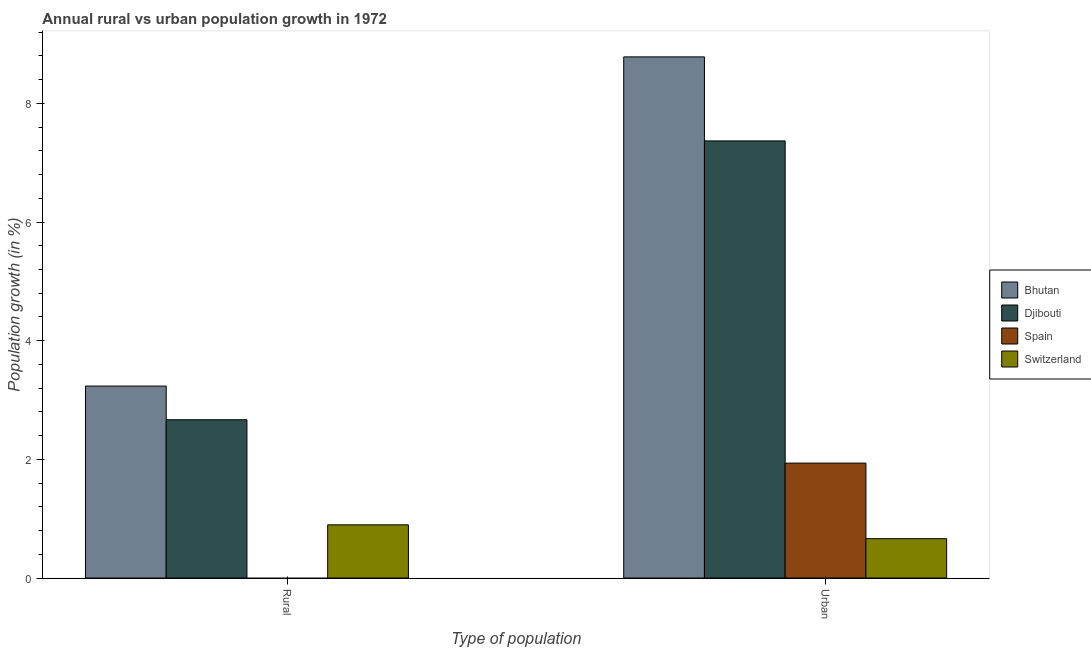Are the number of bars per tick equal to the number of legend labels?
Make the answer very short. No. How many bars are there on the 1st tick from the left?
Your answer should be very brief. 3. How many bars are there on the 1st tick from the right?
Give a very brief answer. 4. What is the label of the 1st group of bars from the left?
Offer a very short reply. Rural. What is the rural population growth in Bhutan?
Keep it short and to the point. 3.24. Across all countries, what is the maximum urban population growth?
Make the answer very short. 8.78. Across all countries, what is the minimum rural population growth?
Provide a short and direct response. 0. In which country was the rural population growth maximum?
Your answer should be very brief. Bhutan. What is the total rural population growth in the graph?
Offer a very short reply. 6.8. What is the difference between the urban population growth in Djibouti and that in Switzerland?
Provide a succinct answer. 6.7. What is the difference between the rural population growth in Spain and the urban population growth in Djibouti?
Keep it short and to the point. -7.37. What is the average rural population growth per country?
Provide a succinct answer. 1.7. What is the difference between the rural population growth and urban population growth in Switzerland?
Offer a terse response. 0.23. What is the ratio of the urban population growth in Spain to that in Bhutan?
Offer a very short reply. 0.22. In how many countries, is the urban population growth greater than the average urban population growth taken over all countries?
Offer a terse response. 2. How many bars are there?
Provide a succinct answer. 7. Are all the bars in the graph horizontal?
Offer a very short reply. No. How many countries are there in the graph?
Provide a short and direct response. 4. Are the values on the major ticks of Y-axis written in scientific E-notation?
Offer a terse response. No. Does the graph contain grids?
Your answer should be compact. No. Where does the legend appear in the graph?
Your answer should be compact. Center right. How many legend labels are there?
Make the answer very short. 4. What is the title of the graph?
Your response must be concise. Annual rural vs urban population growth in 1972. Does "Aruba" appear as one of the legend labels in the graph?
Ensure brevity in your answer.  No. What is the label or title of the X-axis?
Your response must be concise. Type of population. What is the label or title of the Y-axis?
Make the answer very short. Population growth (in %). What is the Population growth (in %) in Bhutan in Rural?
Offer a very short reply. 3.24. What is the Population growth (in %) in Djibouti in Rural?
Keep it short and to the point. 2.67. What is the Population growth (in %) in Spain in Rural?
Your answer should be compact. 0. What is the Population growth (in %) in Switzerland in Rural?
Provide a succinct answer. 0.9. What is the Population growth (in %) of Bhutan in Urban ?
Make the answer very short. 8.78. What is the Population growth (in %) of Djibouti in Urban ?
Offer a very short reply. 7.37. What is the Population growth (in %) in Spain in Urban ?
Your answer should be very brief. 1.94. What is the Population growth (in %) in Switzerland in Urban ?
Offer a terse response. 0.66. Across all Type of population, what is the maximum Population growth (in %) in Bhutan?
Your answer should be very brief. 8.78. Across all Type of population, what is the maximum Population growth (in %) in Djibouti?
Provide a succinct answer. 7.37. Across all Type of population, what is the maximum Population growth (in %) of Spain?
Offer a terse response. 1.94. Across all Type of population, what is the maximum Population growth (in %) in Switzerland?
Offer a very short reply. 0.9. Across all Type of population, what is the minimum Population growth (in %) of Bhutan?
Offer a very short reply. 3.24. Across all Type of population, what is the minimum Population growth (in %) of Djibouti?
Give a very brief answer. 2.67. Across all Type of population, what is the minimum Population growth (in %) of Spain?
Ensure brevity in your answer.  0. Across all Type of population, what is the minimum Population growth (in %) of Switzerland?
Provide a short and direct response. 0.66. What is the total Population growth (in %) of Bhutan in the graph?
Offer a very short reply. 12.02. What is the total Population growth (in %) in Djibouti in the graph?
Provide a short and direct response. 10.04. What is the total Population growth (in %) in Spain in the graph?
Keep it short and to the point. 1.94. What is the total Population growth (in %) of Switzerland in the graph?
Give a very brief answer. 1.56. What is the difference between the Population growth (in %) in Bhutan in Rural and that in Urban ?
Offer a terse response. -5.55. What is the difference between the Population growth (in %) in Djibouti in Rural and that in Urban ?
Ensure brevity in your answer.  -4.7. What is the difference between the Population growth (in %) of Switzerland in Rural and that in Urban ?
Your response must be concise. 0.23. What is the difference between the Population growth (in %) of Bhutan in Rural and the Population growth (in %) of Djibouti in Urban?
Offer a very short reply. -4.13. What is the difference between the Population growth (in %) in Bhutan in Rural and the Population growth (in %) in Spain in Urban?
Keep it short and to the point. 1.3. What is the difference between the Population growth (in %) in Bhutan in Rural and the Population growth (in %) in Switzerland in Urban?
Your response must be concise. 2.57. What is the difference between the Population growth (in %) of Djibouti in Rural and the Population growth (in %) of Spain in Urban?
Make the answer very short. 0.73. What is the difference between the Population growth (in %) in Djibouti in Rural and the Population growth (in %) in Switzerland in Urban?
Your answer should be compact. 2. What is the average Population growth (in %) of Bhutan per Type of population?
Make the answer very short. 6.01. What is the average Population growth (in %) of Djibouti per Type of population?
Ensure brevity in your answer.  5.02. What is the average Population growth (in %) of Spain per Type of population?
Offer a very short reply. 0.97. What is the average Population growth (in %) of Switzerland per Type of population?
Your response must be concise. 0.78. What is the difference between the Population growth (in %) of Bhutan and Population growth (in %) of Djibouti in Rural?
Provide a succinct answer. 0.57. What is the difference between the Population growth (in %) of Bhutan and Population growth (in %) of Switzerland in Rural?
Your answer should be compact. 2.34. What is the difference between the Population growth (in %) in Djibouti and Population growth (in %) in Switzerland in Rural?
Your answer should be compact. 1.77. What is the difference between the Population growth (in %) in Bhutan and Population growth (in %) in Djibouti in Urban ?
Your answer should be compact. 1.42. What is the difference between the Population growth (in %) in Bhutan and Population growth (in %) in Spain in Urban ?
Keep it short and to the point. 6.85. What is the difference between the Population growth (in %) of Bhutan and Population growth (in %) of Switzerland in Urban ?
Offer a terse response. 8.12. What is the difference between the Population growth (in %) in Djibouti and Population growth (in %) in Spain in Urban ?
Make the answer very short. 5.43. What is the difference between the Population growth (in %) of Djibouti and Population growth (in %) of Switzerland in Urban ?
Give a very brief answer. 6.7. What is the difference between the Population growth (in %) of Spain and Population growth (in %) of Switzerland in Urban ?
Your response must be concise. 1.27. What is the ratio of the Population growth (in %) of Bhutan in Rural to that in Urban ?
Give a very brief answer. 0.37. What is the ratio of the Population growth (in %) in Djibouti in Rural to that in Urban ?
Ensure brevity in your answer.  0.36. What is the ratio of the Population growth (in %) of Switzerland in Rural to that in Urban ?
Give a very brief answer. 1.35. What is the difference between the highest and the second highest Population growth (in %) in Bhutan?
Provide a short and direct response. 5.55. What is the difference between the highest and the second highest Population growth (in %) in Djibouti?
Offer a very short reply. 4.7. What is the difference between the highest and the second highest Population growth (in %) of Switzerland?
Your response must be concise. 0.23. What is the difference between the highest and the lowest Population growth (in %) in Bhutan?
Your answer should be very brief. 5.55. What is the difference between the highest and the lowest Population growth (in %) in Djibouti?
Your answer should be compact. 4.7. What is the difference between the highest and the lowest Population growth (in %) of Spain?
Provide a succinct answer. 1.94. What is the difference between the highest and the lowest Population growth (in %) of Switzerland?
Your response must be concise. 0.23. 